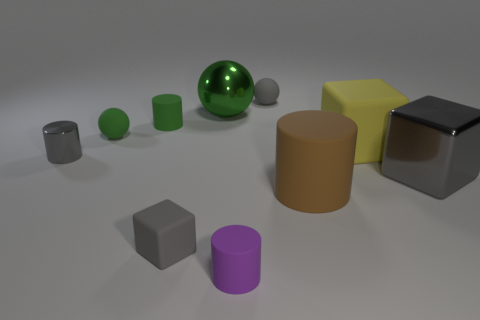What shape is the big matte object that is behind the large brown cylinder right of the tiny gray rubber object behind the small green ball?
Give a very brief answer. Cube. There is a small rubber object that is to the left of the small matte cube and behind the green matte ball; what is its shape?
Provide a short and direct response. Cylinder. How many brown cylinders are behind the gray shiny object right of the tiny cylinder that is to the right of the small green cylinder?
Give a very brief answer. 0. What is the size of the gray thing that is the same shape as the big brown object?
Keep it short and to the point. Small. Do the gray cube that is on the right side of the yellow rubber thing and the gray sphere have the same material?
Give a very brief answer. No. There is a tiny metallic object that is the same shape as the purple rubber object; what is its color?
Provide a short and direct response. Gray. How many other things are the same color as the big matte cylinder?
Your response must be concise. 0. Does the gray shiny object on the right side of the gray shiny cylinder have the same shape as the gray matte thing in front of the gray ball?
Keep it short and to the point. Yes. How many cylinders are brown matte objects or small metal objects?
Offer a terse response. 2. Are there fewer green matte things on the right side of the purple matte cylinder than large metallic objects?
Your answer should be very brief. Yes. 